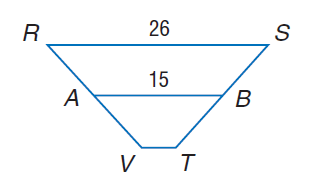Answer the mathemtical geometry problem and directly provide the correct option letter.
Question: For trapezoid R S T V, A and B are midpoints of the legs. Find V T.
Choices: A: 4 B: 8 C: 26 D: 30 A 